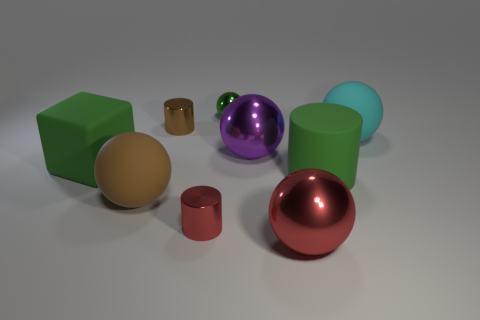Subtract all red spheres. How many spheres are left? 4 Subtract all gray spheres. Subtract all brown cubes. How many spheres are left? 5 Add 1 cyan matte cylinders. How many objects exist? 10 Subtract all balls. How many objects are left? 4 Add 3 small cyan objects. How many small cyan objects exist? 3 Subtract 1 brown balls. How many objects are left? 8 Subtract all big purple shiny objects. Subtract all red metal cylinders. How many objects are left? 7 Add 3 small brown shiny cylinders. How many small brown shiny cylinders are left? 4 